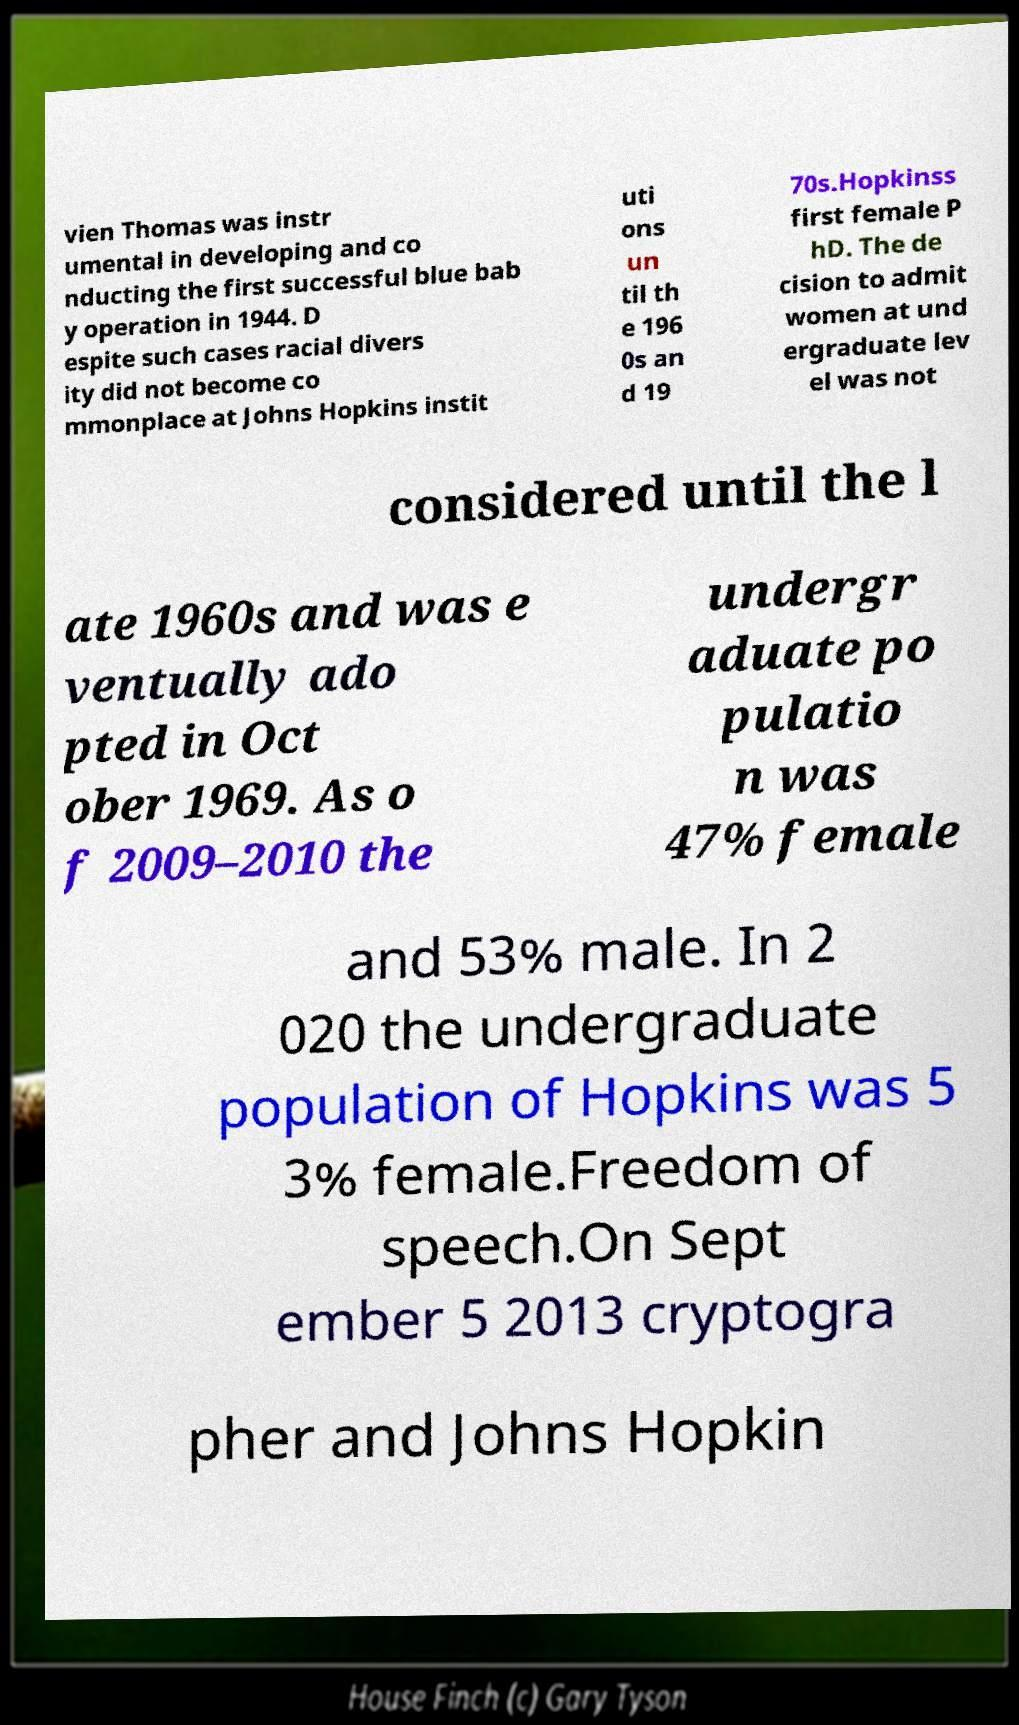Could you assist in decoding the text presented in this image and type it out clearly? vien Thomas was instr umental in developing and co nducting the first successful blue bab y operation in 1944. D espite such cases racial divers ity did not become co mmonplace at Johns Hopkins instit uti ons un til th e 196 0s an d 19 70s.Hopkinss first female P hD. The de cision to admit women at und ergraduate lev el was not considered until the l ate 1960s and was e ventually ado pted in Oct ober 1969. As o f 2009–2010 the undergr aduate po pulatio n was 47% female and 53% male. In 2 020 the undergraduate population of Hopkins was 5 3% female.Freedom of speech.On Sept ember 5 2013 cryptogra pher and Johns Hopkin 